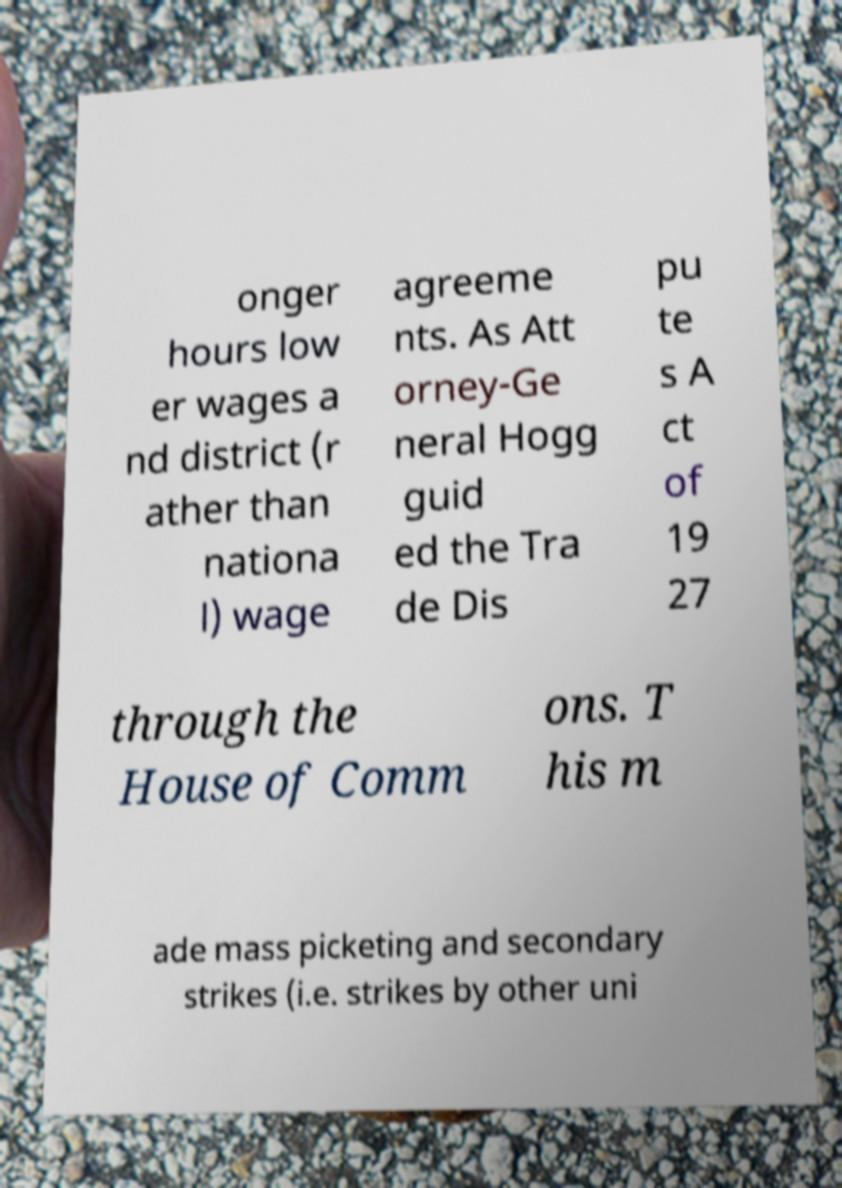Could you extract and type out the text from this image? onger hours low er wages a nd district (r ather than nationa l) wage agreeme nts. As Att orney-Ge neral Hogg guid ed the Tra de Dis pu te s A ct of 19 27 through the House of Comm ons. T his m ade mass picketing and secondary strikes (i.e. strikes by other uni 